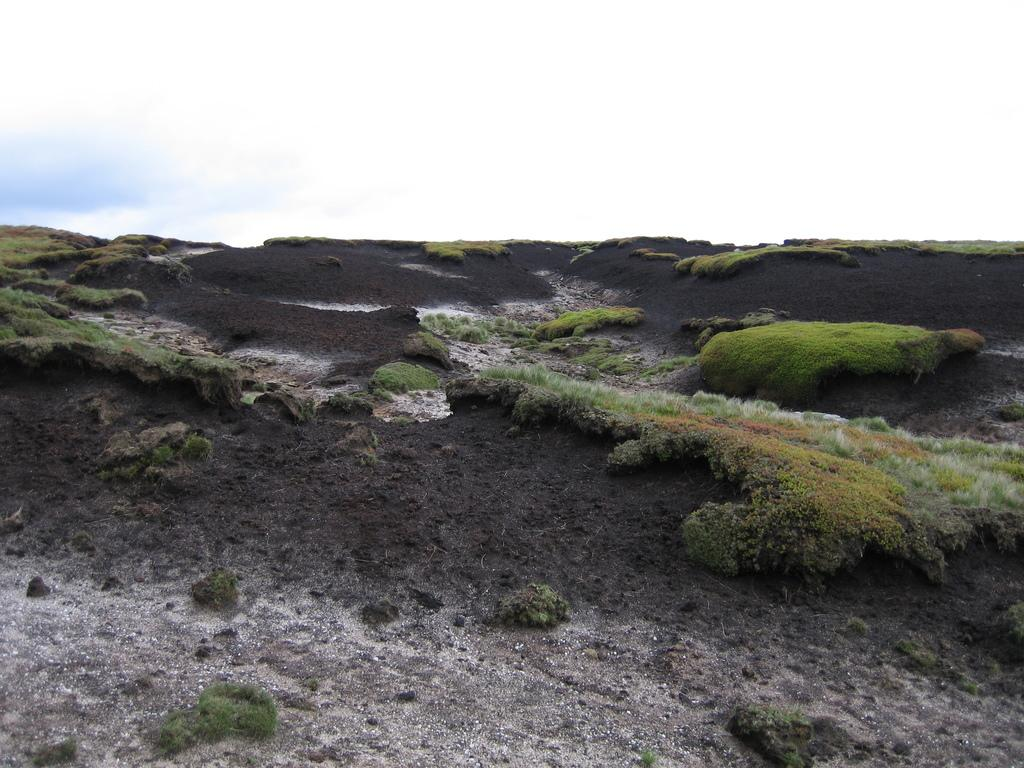Where was the image taken? The image was taken outdoors. What can be seen in the sky in the image? There is a sky with clouds visible in the image. What type of surface is visible on the ground in the image? There is a ground with grass in the image. What type of humor is depicted in the image? There is no humor depicted in the image; it features a sky with clouds and a ground with grass. What date is shown on the calendar in the image? There is no calendar present in the image. 